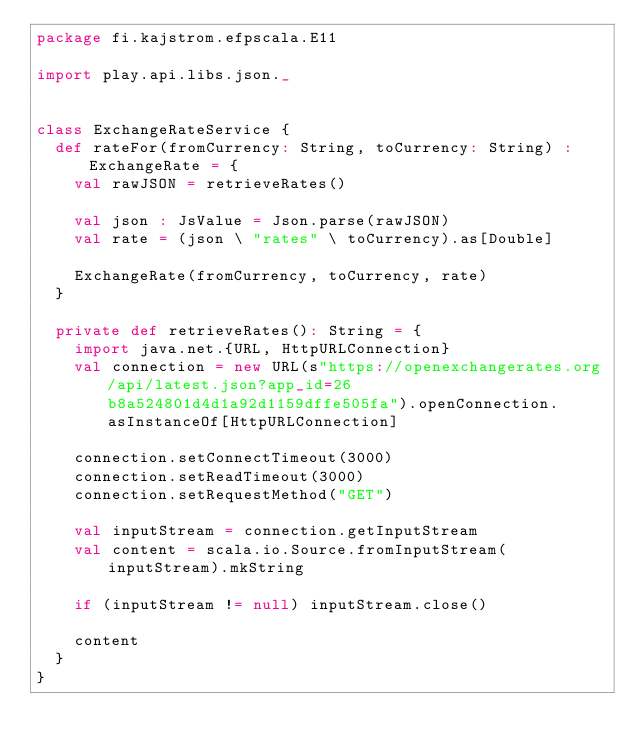<code> <loc_0><loc_0><loc_500><loc_500><_Scala_>package fi.kajstrom.efpscala.E11

import play.api.libs.json._


class ExchangeRateService {
  def rateFor(fromCurrency: String, toCurrency: String) : ExchangeRate = {
    val rawJSON = retrieveRates()

    val json : JsValue = Json.parse(rawJSON)
    val rate = (json \ "rates" \ toCurrency).as[Double]

    ExchangeRate(fromCurrency, toCurrency, rate)
  }

  private def retrieveRates(): String = {
    import java.net.{URL, HttpURLConnection}
    val connection = new URL(s"https://openexchangerates.org/api/latest.json?app_id=26b8a524801d4d1a92d1159dffe505fa").openConnection.asInstanceOf[HttpURLConnection]

    connection.setConnectTimeout(3000)
    connection.setReadTimeout(3000)
    connection.setRequestMethod("GET")

    val inputStream = connection.getInputStream
    val content = scala.io.Source.fromInputStream(inputStream).mkString

    if (inputStream != null) inputStream.close()

    content
  }
}
</code> 